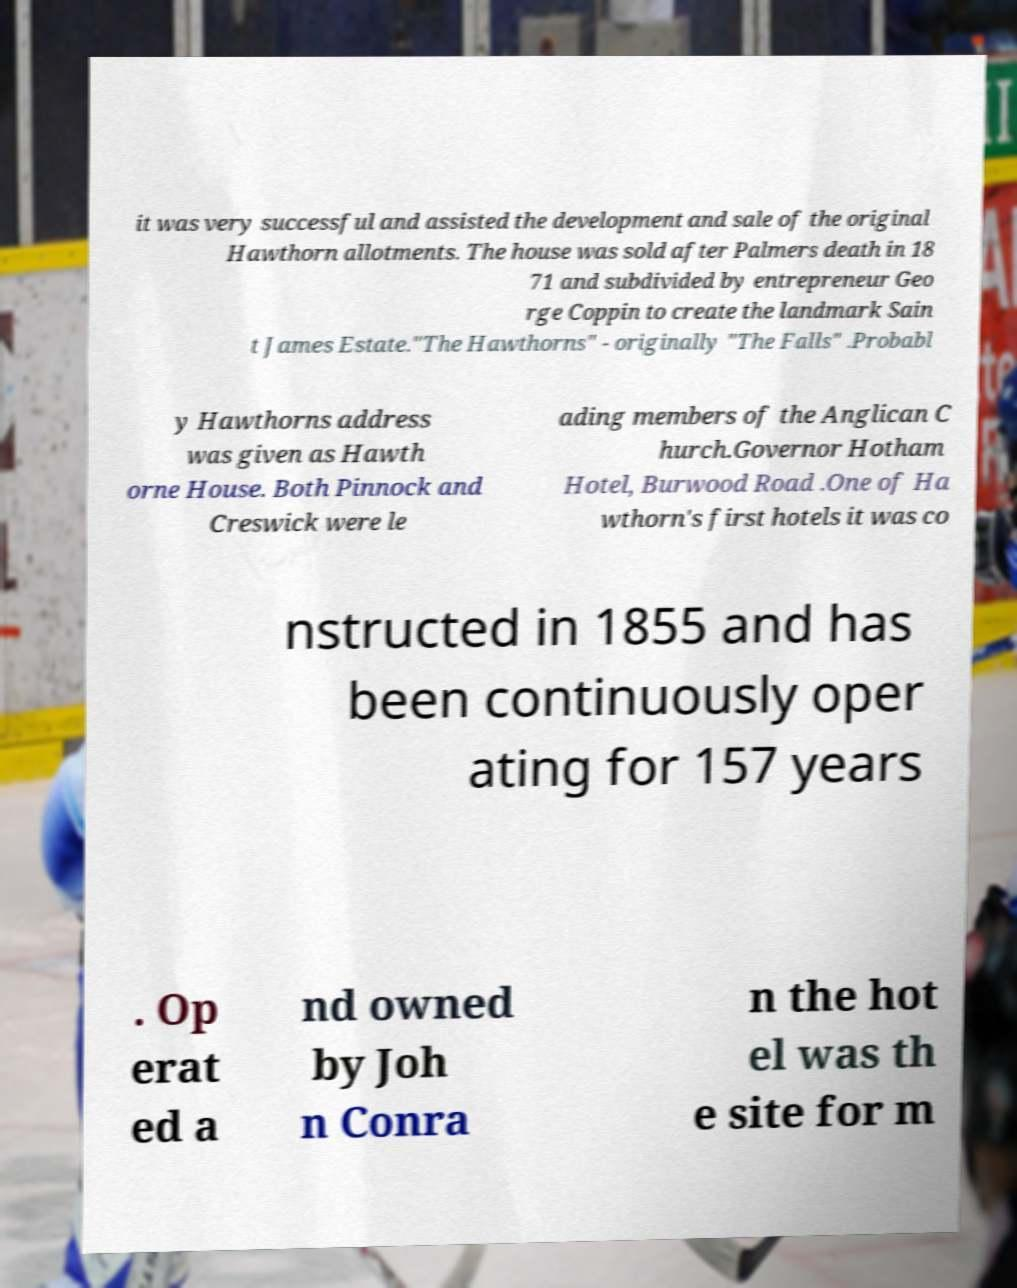There's text embedded in this image that I need extracted. Can you transcribe it verbatim? it was very successful and assisted the development and sale of the original Hawthorn allotments. The house was sold after Palmers death in 18 71 and subdivided by entrepreneur Geo rge Coppin to create the landmark Sain t James Estate."The Hawthorns" - originally "The Falls" .Probabl y Hawthorns address was given as Hawth orne House. Both Pinnock and Creswick were le ading members of the Anglican C hurch.Governor Hotham Hotel, Burwood Road .One of Ha wthorn's first hotels it was co nstructed in 1855 and has been continuously oper ating for 157 years . Op erat ed a nd owned by Joh n Conra n the hot el was th e site for m 